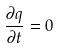Convert formula to latex. <formula><loc_0><loc_0><loc_500><loc_500>\frac { \partial q } { \partial t } = 0</formula> 